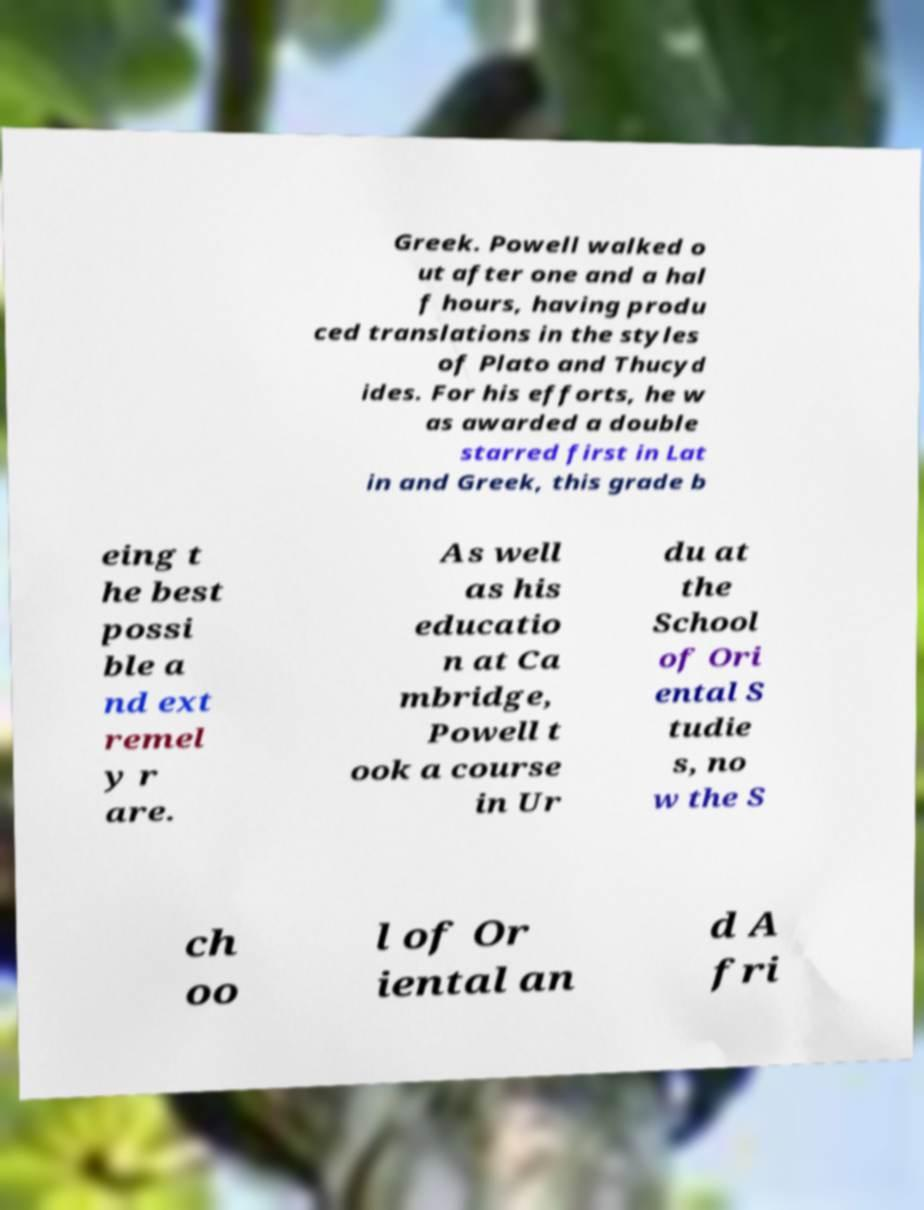What messages or text are displayed in this image? I need them in a readable, typed format. Greek. Powell walked o ut after one and a hal f hours, having produ ced translations in the styles of Plato and Thucyd ides. For his efforts, he w as awarded a double starred first in Lat in and Greek, this grade b eing t he best possi ble a nd ext remel y r are. As well as his educatio n at Ca mbridge, Powell t ook a course in Ur du at the School of Ori ental S tudie s, no w the S ch oo l of Or iental an d A fri 